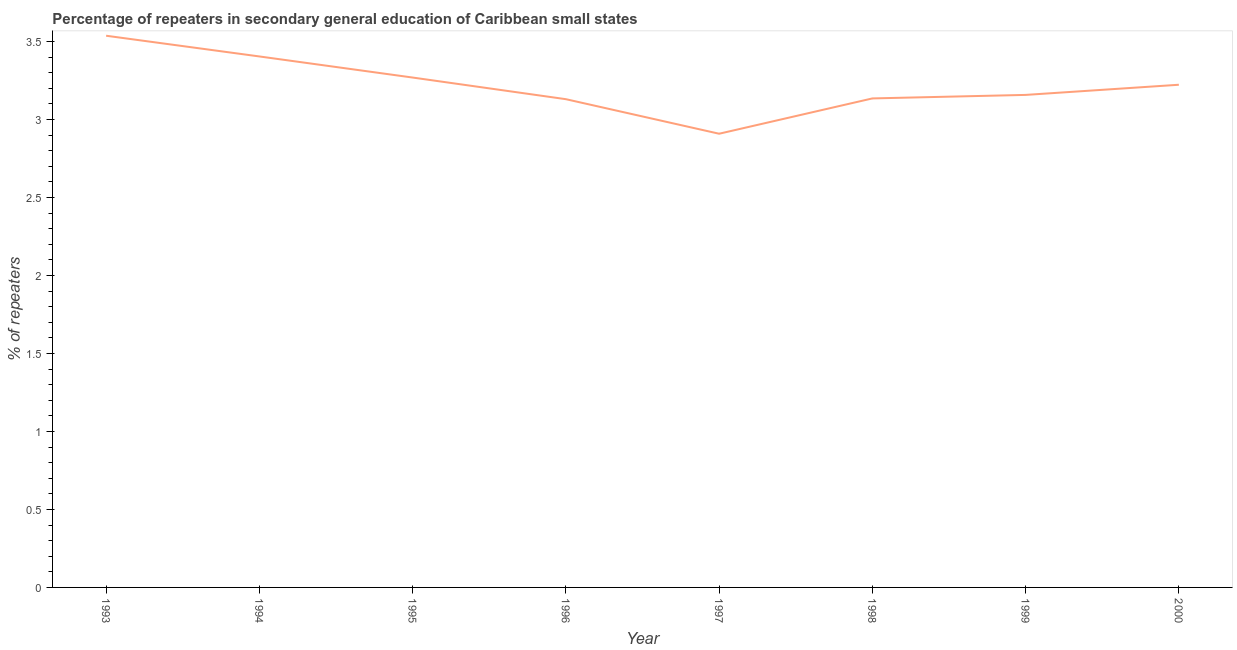What is the percentage of repeaters in 1996?
Provide a succinct answer. 3.13. Across all years, what is the maximum percentage of repeaters?
Provide a short and direct response. 3.54. Across all years, what is the minimum percentage of repeaters?
Offer a very short reply. 2.91. What is the sum of the percentage of repeaters?
Your response must be concise. 25.77. What is the difference between the percentage of repeaters in 1996 and 2000?
Your response must be concise. -0.09. What is the average percentage of repeaters per year?
Provide a short and direct response. 3.22. What is the median percentage of repeaters?
Give a very brief answer. 3.19. In how many years, is the percentage of repeaters greater than 1.6 %?
Offer a terse response. 8. Do a majority of the years between 1993 and 1997 (inclusive) have percentage of repeaters greater than 0.6 %?
Your answer should be compact. Yes. What is the ratio of the percentage of repeaters in 1998 to that in 2000?
Your response must be concise. 0.97. Is the difference between the percentage of repeaters in 1995 and 1997 greater than the difference between any two years?
Offer a very short reply. No. What is the difference between the highest and the second highest percentage of repeaters?
Provide a succinct answer. 0.13. Is the sum of the percentage of repeaters in 1997 and 2000 greater than the maximum percentage of repeaters across all years?
Your answer should be compact. Yes. What is the difference between the highest and the lowest percentage of repeaters?
Give a very brief answer. 0.63. In how many years, is the percentage of repeaters greater than the average percentage of repeaters taken over all years?
Provide a succinct answer. 4. Does the percentage of repeaters monotonically increase over the years?
Offer a terse response. No. How many lines are there?
Provide a short and direct response. 1. How many years are there in the graph?
Offer a very short reply. 8. What is the difference between two consecutive major ticks on the Y-axis?
Your answer should be very brief. 0.5. Are the values on the major ticks of Y-axis written in scientific E-notation?
Your response must be concise. No. Does the graph contain any zero values?
Your answer should be compact. No. Does the graph contain grids?
Ensure brevity in your answer.  No. What is the title of the graph?
Your answer should be compact. Percentage of repeaters in secondary general education of Caribbean small states. What is the label or title of the Y-axis?
Offer a terse response. % of repeaters. What is the % of repeaters in 1993?
Make the answer very short. 3.54. What is the % of repeaters of 1994?
Your response must be concise. 3.4. What is the % of repeaters of 1995?
Your answer should be very brief. 3.27. What is the % of repeaters in 1996?
Provide a succinct answer. 3.13. What is the % of repeaters of 1997?
Your answer should be compact. 2.91. What is the % of repeaters in 1998?
Offer a terse response. 3.14. What is the % of repeaters of 1999?
Your answer should be very brief. 3.16. What is the % of repeaters of 2000?
Offer a very short reply. 3.22. What is the difference between the % of repeaters in 1993 and 1994?
Keep it short and to the point. 0.13. What is the difference between the % of repeaters in 1993 and 1995?
Make the answer very short. 0.27. What is the difference between the % of repeaters in 1993 and 1996?
Ensure brevity in your answer.  0.41. What is the difference between the % of repeaters in 1993 and 1997?
Your response must be concise. 0.63. What is the difference between the % of repeaters in 1993 and 1998?
Your answer should be compact. 0.4. What is the difference between the % of repeaters in 1993 and 1999?
Your answer should be compact. 0.38. What is the difference between the % of repeaters in 1993 and 2000?
Make the answer very short. 0.31. What is the difference between the % of repeaters in 1994 and 1995?
Give a very brief answer. 0.14. What is the difference between the % of repeaters in 1994 and 1996?
Your answer should be compact. 0.27. What is the difference between the % of repeaters in 1994 and 1997?
Keep it short and to the point. 0.5. What is the difference between the % of repeaters in 1994 and 1998?
Your answer should be compact. 0.27. What is the difference between the % of repeaters in 1994 and 1999?
Provide a succinct answer. 0.25. What is the difference between the % of repeaters in 1994 and 2000?
Offer a terse response. 0.18. What is the difference between the % of repeaters in 1995 and 1996?
Offer a terse response. 0.14. What is the difference between the % of repeaters in 1995 and 1997?
Keep it short and to the point. 0.36. What is the difference between the % of repeaters in 1995 and 1998?
Keep it short and to the point. 0.13. What is the difference between the % of repeaters in 1995 and 1999?
Offer a terse response. 0.11. What is the difference between the % of repeaters in 1995 and 2000?
Ensure brevity in your answer.  0.05. What is the difference between the % of repeaters in 1996 and 1997?
Your answer should be compact. 0.22. What is the difference between the % of repeaters in 1996 and 1998?
Your response must be concise. -0. What is the difference between the % of repeaters in 1996 and 1999?
Offer a very short reply. -0.03. What is the difference between the % of repeaters in 1996 and 2000?
Make the answer very short. -0.09. What is the difference between the % of repeaters in 1997 and 1998?
Provide a succinct answer. -0.23. What is the difference between the % of repeaters in 1997 and 1999?
Offer a very short reply. -0.25. What is the difference between the % of repeaters in 1997 and 2000?
Give a very brief answer. -0.31. What is the difference between the % of repeaters in 1998 and 1999?
Keep it short and to the point. -0.02. What is the difference between the % of repeaters in 1998 and 2000?
Keep it short and to the point. -0.09. What is the difference between the % of repeaters in 1999 and 2000?
Your response must be concise. -0.07. What is the ratio of the % of repeaters in 1993 to that in 1994?
Provide a succinct answer. 1.04. What is the ratio of the % of repeaters in 1993 to that in 1995?
Your answer should be very brief. 1.08. What is the ratio of the % of repeaters in 1993 to that in 1996?
Keep it short and to the point. 1.13. What is the ratio of the % of repeaters in 1993 to that in 1997?
Your answer should be compact. 1.22. What is the ratio of the % of repeaters in 1993 to that in 1998?
Your response must be concise. 1.13. What is the ratio of the % of repeaters in 1993 to that in 1999?
Your answer should be very brief. 1.12. What is the ratio of the % of repeaters in 1993 to that in 2000?
Your answer should be very brief. 1.1. What is the ratio of the % of repeaters in 1994 to that in 1995?
Give a very brief answer. 1.04. What is the ratio of the % of repeaters in 1994 to that in 1996?
Provide a short and direct response. 1.09. What is the ratio of the % of repeaters in 1994 to that in 1997?
Your answer should be very brief. 1.17. What is the ratio of the % of repeaters in 1994 to that in 1998?
Offer a terse response. 1.09. What is the ratio of the % of repeaters in 1994 to that in 1999?
Your answer should be very brief. 1.08. What is the ratio of the % of repeaters in 1994 to that in 2000?
Provide a short and direct response. 1.06. What is the ratio of the % of repeaters in 1995 to that in 1996?
Make the answer very short. 1.04. What is the ratio of the % of repeaters in 1995 to that in 1997?
Your answer should be compact. 1.12. What is the ratio of the % of repeaters in 1995 to that in 1998?
Give a very brief answer. 1.04. What is the ratio of the % of repeaters in 1995 to that in 1999?
Offer a terse response. 1.03. What is the ratio of the % of repeaters in 1996 to that in 1997?
Your response must be concise. 1.08. What is the ratio of the % of repeaters in 1996 to that in 1998?
Keep it short and to the point. 1. What is the ratio of the % of repeaters in 1996 to that in 1999?
Your answer should be very brief. 0.99. What is the ratio of the % of repeaters in 1996 to that in 2000?
Make the answer very short. 0.97. What is the ratio of the % of repeaters in 1997 to that in 1998?
Your response must be concise. 0.93. What is the ratio of the % of repeaters in 1997 to that in 1999?
Give a very brief answer. 0.92. What is the ratio of the % of repeaters in 1997 to that in 2000?
Your response must be concise. 0.9. What is the ratio of the % of repeaters in 1998 to that in 2000?
Your answer should be very brief. 0.97. 